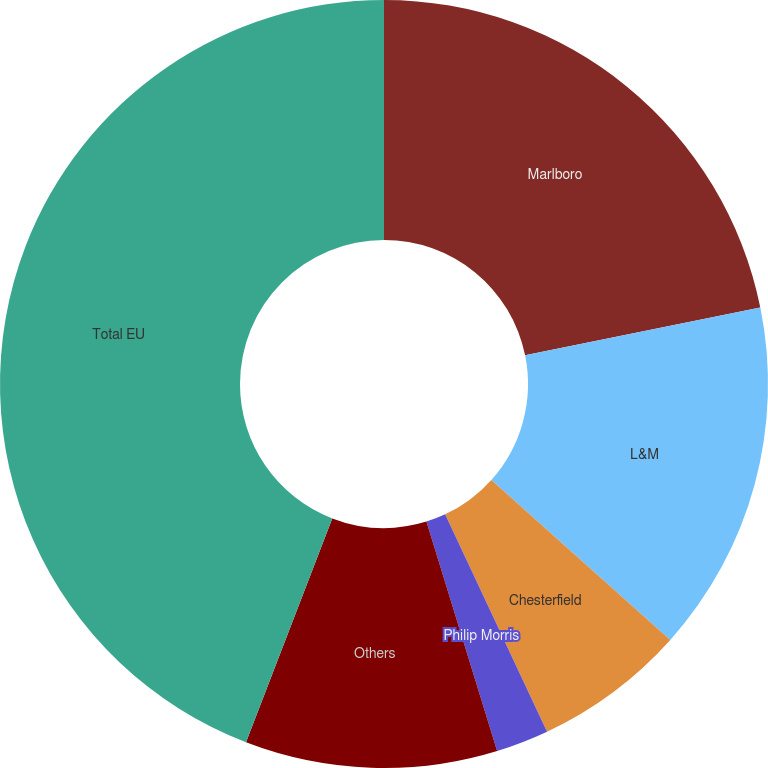<chart> <loc_0><loc_0><loc_500><loc_500><pie_chart><fcel>Marlboro<fcel>L&M<fcel>Chesterfield<fcel>Philip Morris<fcel>Others<fcel>Total EU<nl><fcel>21.81%<fcel>14.8%<fcel>6.41%<fcel>2.22%<fcel>10.61%<fcel>44.15%<nl></chart> 